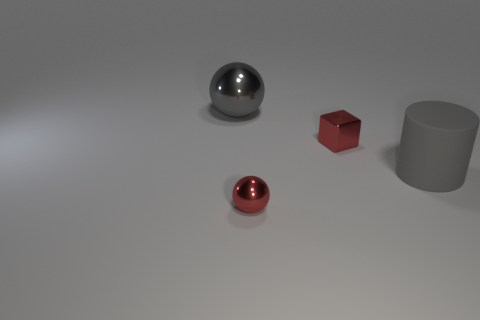Add 4 blue cubes. How many objects exist? 8 Subtract all gray balls. How many balls are left? 1 Subtract 0 brown blocks. How many objects are left? 4 Subtract all cylinders. How many objects are left? 3 Subtract 1 spheres. How many spheres are left? 1 Subtract all blue spheres. Subtract all brown cylinders. How many spheres are left? 2 Subtract all rubber cylinders. Subtract all large cylinders. How many objects are left? 2 Add 4 big gray rubber cylinders. How many big gray rubber cylinders are left? 5 Add 4 large shiny cubes. How many large shiny cubes exist? 4 